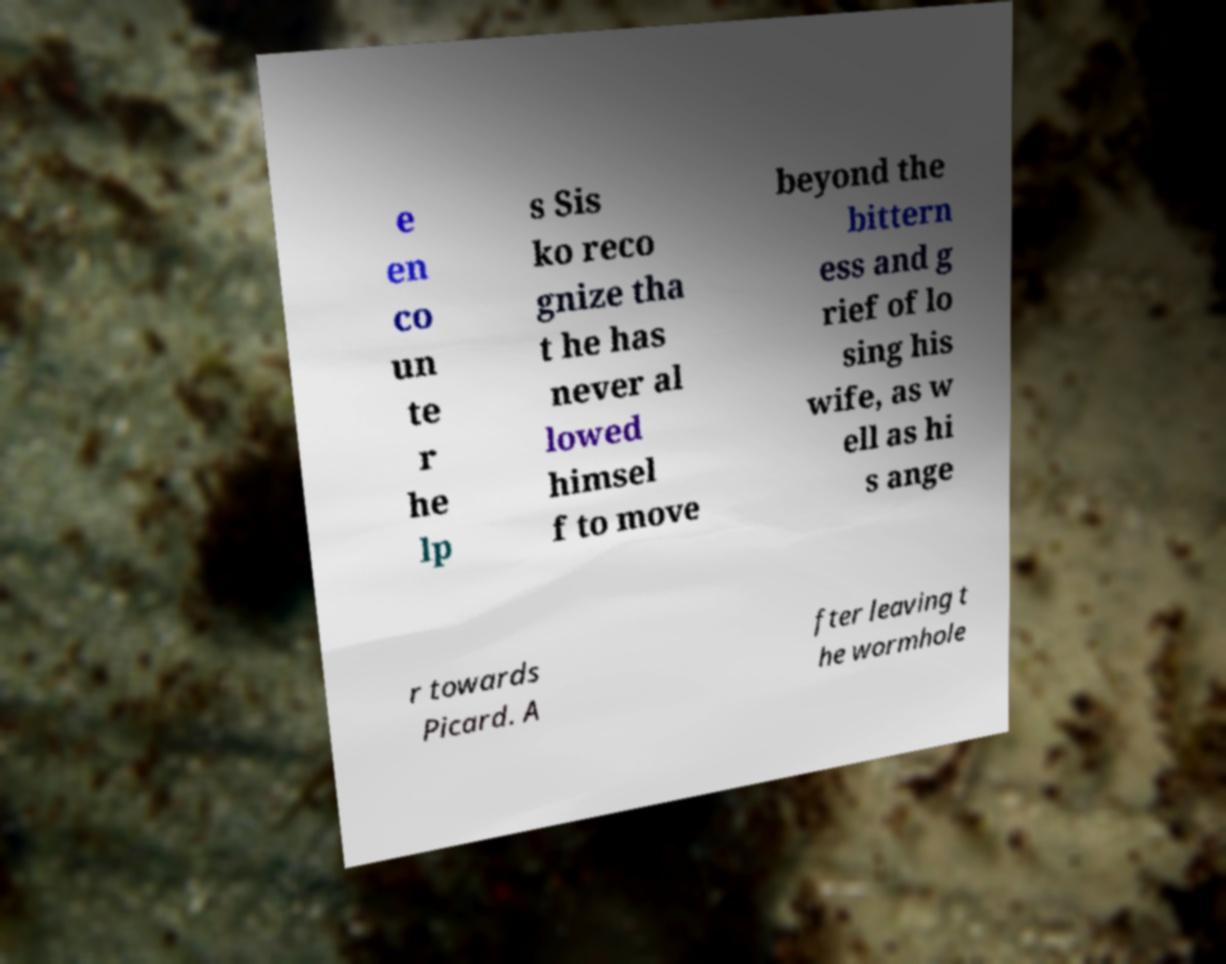Could you extract and type out the text from this image? e en co un te r he lp s Sis ko reco gnize tha t he has never al lowed himsel f to move beyond the bittern ess and g rief of lo sing his wife, as w ell as hi s ange r towards Picard. A fter leaving t he wormhole 